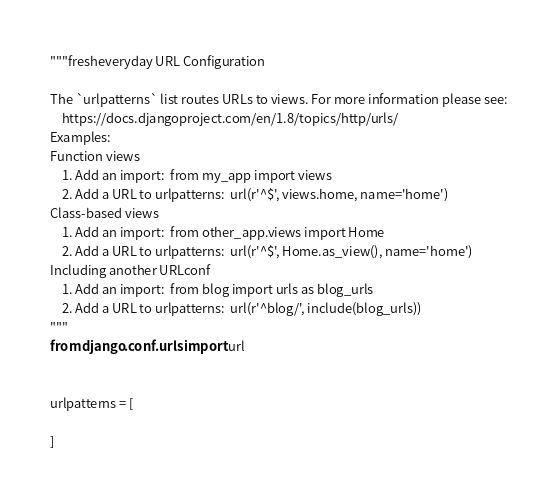Convert code to text. <code><loc_0><loc_0><loc_500><loc_500><_Python_>"""fresheveryday URL Configuration

The `urlpatterns` list routes URLs to views. For more information please see:
    https://docs.djangoproject.com/en/1.8/topics/http/urls/
Examples:
Function views
    1. Add an import:  from my_app import views
    2. Add a URL to urlpatterns:  url(r'^$', views.home, name='home')
Class-based views
    1. Add an import:  from other_app.views import Home
    2. Add a URL to urlpatterns:  url(r'^$', Home.as_view(), name='home')
Including another URLconf
    1. Add an import:  from blog import urls as blog_urls
    2. Add a URL to urlpatterns:  url(r'^blog/', include(blog_urls))
"""
from django.conf.urls import url


urlpatterns = [

]
</code> 